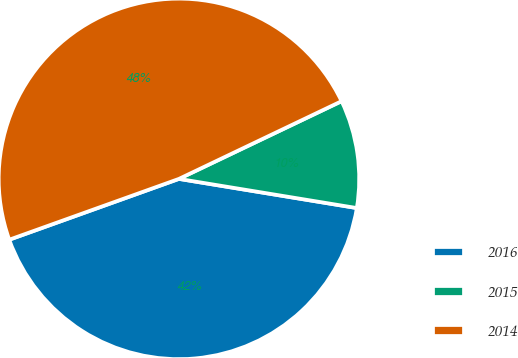Convert chart. <chart><loc_0><loc_0><loc_500><loc_500><pie_chart><fcel>2016<fcel>2015<fcel>2014<nl><fcel>41.94%<fcel>9.68%<fcel>48.39%<nl></chart> 